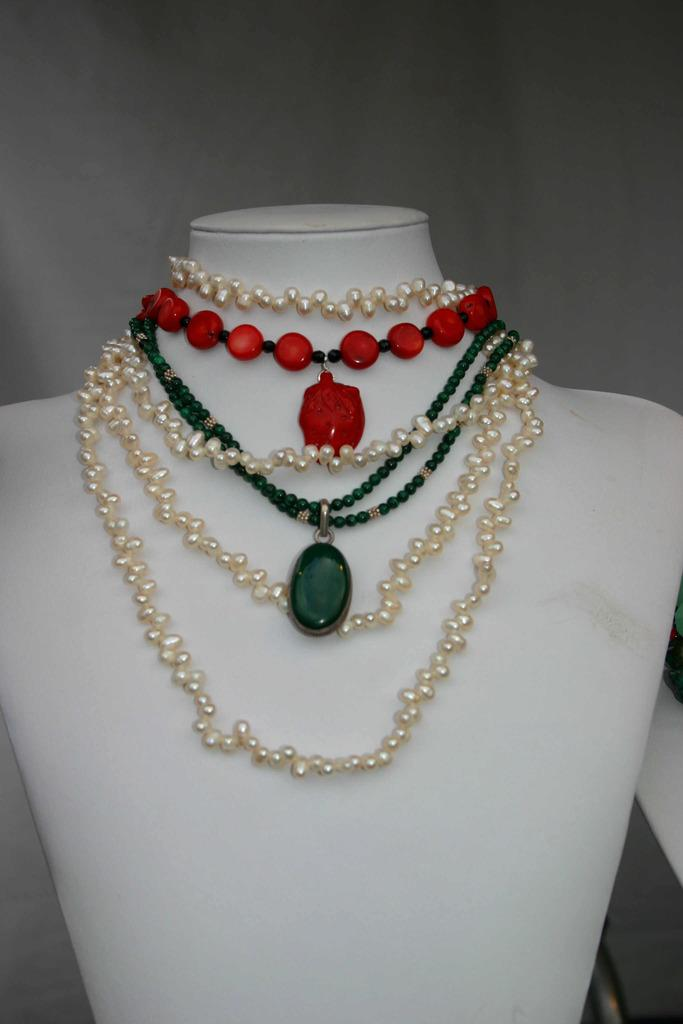What is the main object in the image? There is a jewelry stand in the image. What type of jewelry can be seen on the stand? The jewelry stand has pearl necklaces and necklaces with colored beads. What color is the gold needle on the jewelry stand? There is no gold needle present on the jewelry stand in the image. 